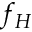<formula> <loc_0><loc_0><loc_500><loc_500>f _ { H }</formula> 